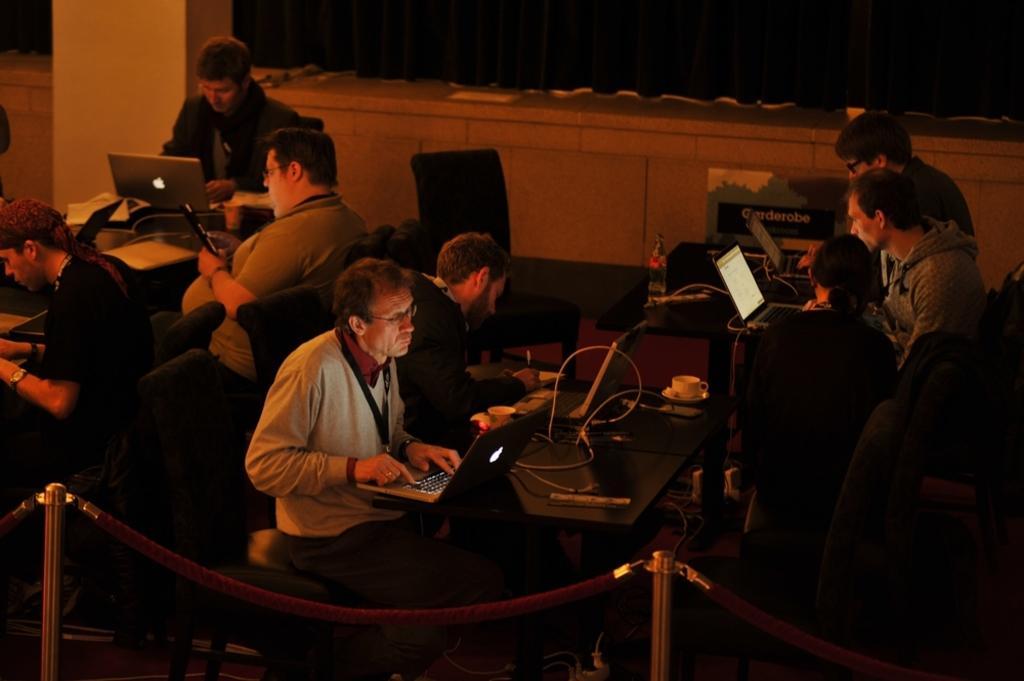Describe this image in one or two sentences. This picture describes about group of people, they are all seated on the chairs, in front of them we can see few laptops, cups, cables and other things on the table, and also we can see few metal rods. 